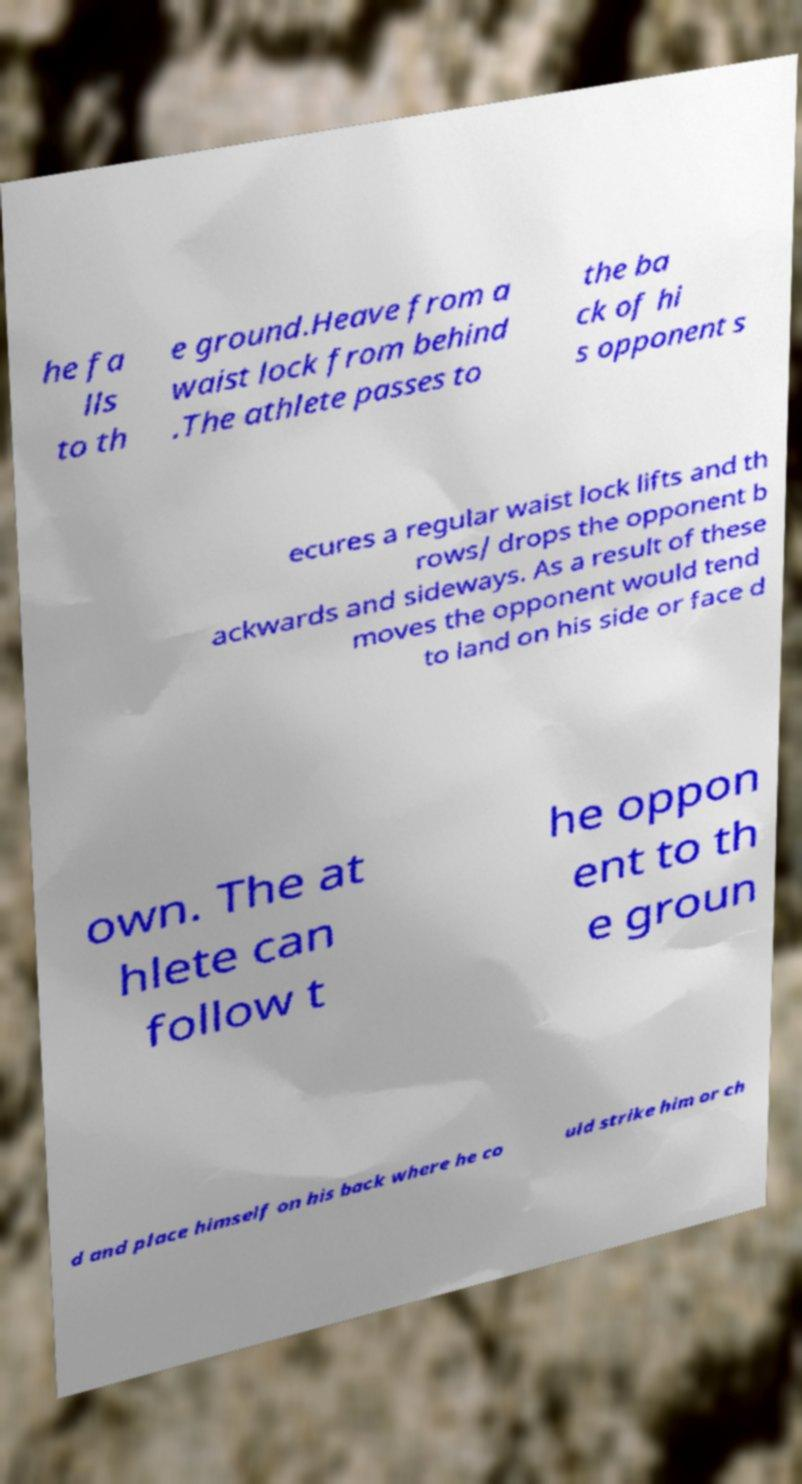What messages or text are displayed in this image? I need them in a readable, typed format. he fa lls to th e ground.Heave from a waist lock from behind .The athlete passes to the ba ck of hi s opponent s ecures a regular waist lock lifts and th rows/ drops the opponent b ackwards and sideways. As a result of these moves the opponent would tend to land on his side or face d own. The at hlete can follow t he oppon ent to th e groun d and place himself on his back where he co uld strike him or ch 